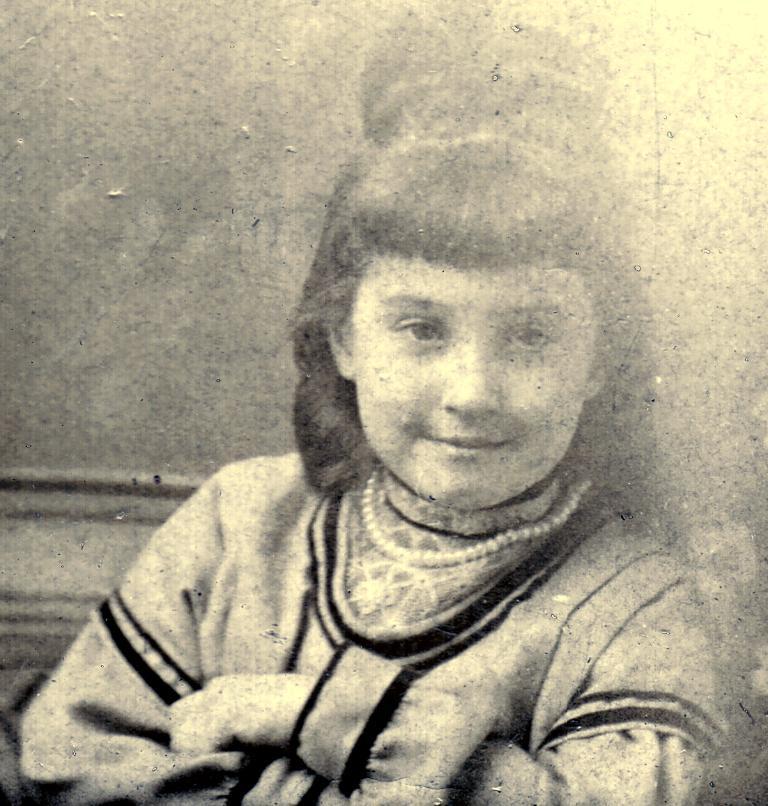Could you give a brief overview of what you see in this image? In this image we can see , in the foreground there is a girl wearing pearl necklace. 